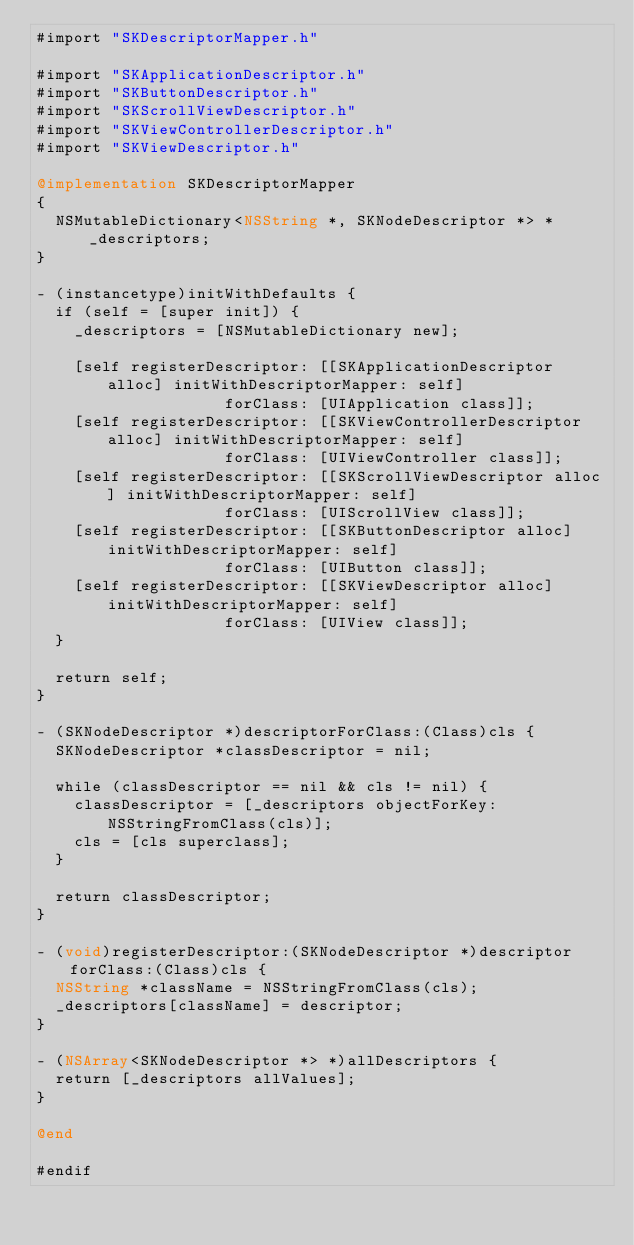<code> <loc_0><loc_0><loc_500><loc_500><_ObjectiveC_>#import "SKDescriptorMapper.h"

#import "SKApplicationDescriptor.h"
#import "SKButtonDescriptor.h"
#import "SKScrollViewDescriptor.h"
#import "SKViewControllerDescriptor.h"
#import "SKViewDescriptor.h"

@implementation SKDescriptorMapper
{
  NSMutableDictionary<NSString *, SKNodeDescriptor *> *_descriptors;
}

- (instancetype)initWithDefaults {
  if (self = [super init]) {
    _descriptors = [NSMutableDictionary new];

    [self registerDescriptor: [[SKApplicationDescriptor alloc] initWithDescriptorMapper: self]
                    forClass: [UIApplication class]];
    [self registerDescriptor: [[SKViewControllerDescriptor alloc] initWithDescriptorMapper: self]
                    forClass: [UIViewController class]];
    [self registerDescriptor: [[SKScrollViewDescriptor alloc] initWithDescriptorMapper: self]
                    forClass: [UIScrollView class]];
    [self registerDescriptor: [[SKButtonDescriptor alloc] initWithDescriptorMapper: self]
                    forClass: [UIButton class]];
    [self registerDescriptor: [[SKViewDescriptor alloc] initWithDescriptorMapper: self]
                    forClass: [UIView class]];
  }

  return self;
}

- (SKNodeDescriptor *)descriptorForClass:(Class)cls {
  SKNodeDescriptor *classDescriptor = nil;

  while (classDescriptor == nil && cls != nil) {
    classDescriptor = [_descriptors objectForKey: NSStringFromClass(cls)];
    cls = [cls superclass];
  }

  return classDescriptor;
}

- (void)registerDescriptor:(SKNodeDescriptor *)descriptor forClass:(Class)cls {
  NSString *className = NSStringFromClass(cls);
  _descriptors[className] = descriptor;
}

- (NSArray<SKNodeDescriptor *> *)allDescriptors {
  return [_descriptors allValues];
}

@end

#endif
</code> 